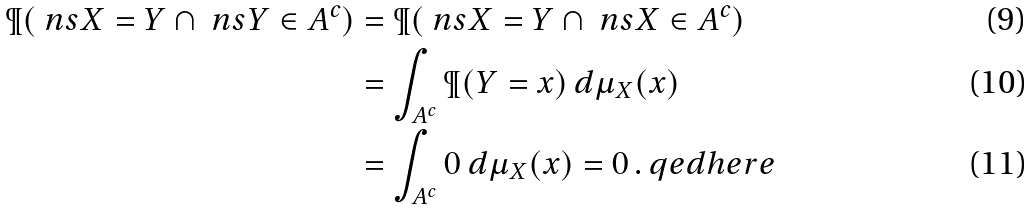<formula> <loc_0><loc_0><loc_500><loc_500>\P ( \ n s { X = Y } \cap \ n s { Y \in A ^ { c } } ) & = \P ( \ n s { X = Y } \cap \ n s { X \in A ^ { c } } ) \\ & = \int _ { A ^ { c } } \P ( Y = x ) \, d \mu _ { X } ( x ) \\ & = \int _ { A ^ { c } } 0 \ d \mu _ { X } ( x ) = 0 \, . \ q e d h e r e</formula> 